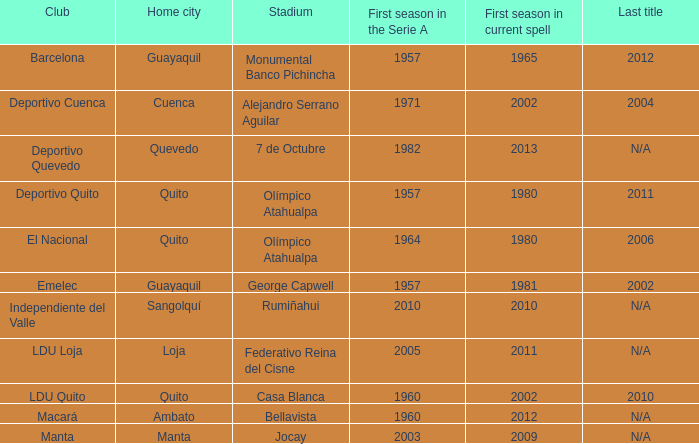Identify the last title awarded in 2012. N/A. 